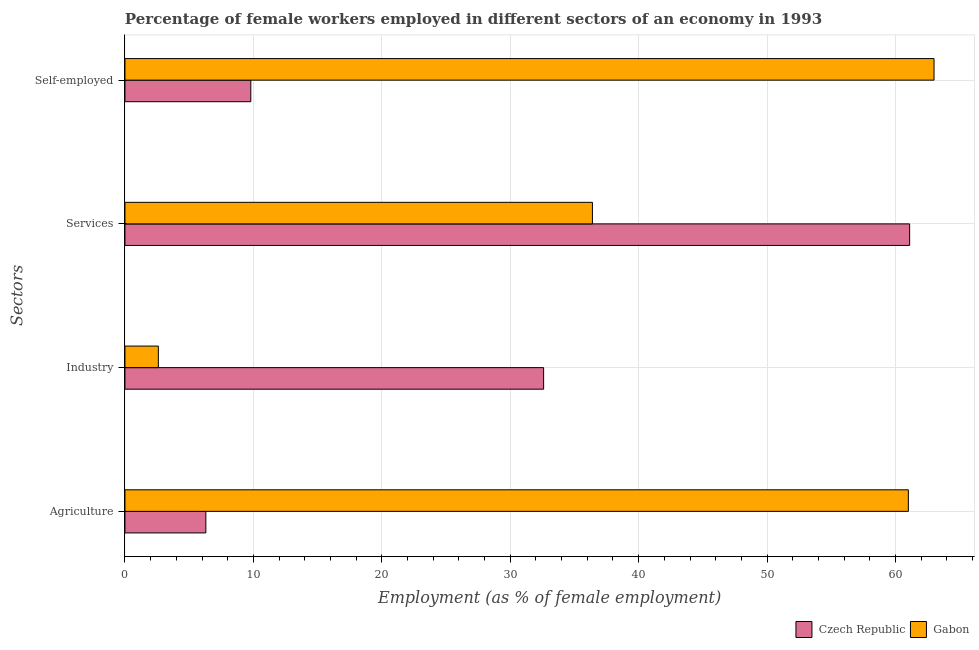How many different coloured bars are there?
Your answer should be compact. 2. How many groups of bars are there?
Make the answer very short. 4. Are the number of bars on each tick of the Y-axis equal?
Give a very brief answer. Yes. What is the label of the 1st group of bars from the top?
Provide a short and direct response. Self-employed. What is the percentage of female workers in services in Czech Republic?
Your response must be concise. 61.1. Across all countries, what is the minimum percentage of female workers in services?
Keep it short and to the point. 36.4. In which country was the percentage of female workers in agriculture maximum?
Provide a short and direct response. Gabon. In which country was the percentage of female workers in services minimum?
Your answer should be very brief. Gabon. What is the total percentage of female workers in agriculture in the graph?
Make the answer very short. 67.3. What is the difference between the percentage of female workers in agriculture in Gabon and that in Czech Republic?
Your answer should be very brief. 54.7. What is the difference between the percentage of female workers in agriculture in Czech Republic and the percentage of female workers in industry in Gabon?
Ensure brevity in your answer.  3.7. What is the average percentage of female workers in services per country?
Keep it short and to the point. 48.75. What is the difference between the percentage of female workers in agriculture and percentage of female workers in services in Gabon?
Provide a short and direct response. 24.6. In how many countries, is the percentage of female workers in services greater than 22 %?
Your response must be concise. 2. What is the ratio of the percentage of female workers in services in Czech Republic to that in Gabon?
Provide a succinct answer. 1.68. Is the percentage of female workers in services in Gabon less than that in Czech Republic?
Offer a very short reply. Yes. What is the difference between the highest and the second highest percentage of female workers in industry?
Your answer should be very brief. 30. What is the difference between the highest and the lowest percentage of female workers in industry?
Your answer should be compact. 30. In how many countries, is the percentage of female workers in industry greater than the average percentage of female workers in industry taken over all countries?
Ensure brevity in your answer.  1. What does the 2nd bar from the top in Self-employed represents?
Ensure brevity in your answer.  Czech Republic. What does the 1st bar from the bottom in Agriculture represents?
Your answer should be very brief. Czech Republic. How many bars are there?
Keep it short and to the point. 8. Are all the bars in the graph horizontal?
Offer a very short reply. Yes. What is the difference between two consecutive major ticks on the X-axis?
Your answer should be compact. 10. Are the values on the major ticks of X-axis written in scientific E-notation?
Provide a succinct answer. No. How are the legend labels stacked?
Provide a short and direct response. Horizontal. What is the title of the graph?
Your answer should be compact. Percentage of female workers employed in different sectors of an economy in 1993. Does "United Kingdom" appear as one of the legend labels in the graph?
Give a very brief answer. No. What is the label or title of the X-axis?
Give a very brief answer. Employment (as % of female employment). What is the label or title of the Y-axis?
Your answer should be compact. Sectors. What is the Employment (as % of female employment) of Czech Republic in Agriculture?
Offer a terse response. 6.3. What is the Employment (as % of female employment) of Gabon in Agriculture?
Offer a very short reply. 61. What is the Employment (as % of female employment) in Czech Republic in Industry?
Give a very brief answer. 32.6. What is the Employment (as % of female employment) of Gabon in Industry?
Offer a very short reply. 2.6. What is the Employment (as % of female employment) in Czech Republic in Services?
Provide a short and direct response. 61.1. What is the Employment (as % of female employment) in Gabon in Services?
Ensure brevity in your answer.  36.4. What is the Employment (as % of female employment) in Czech Republic in Self-employed?
Give a very brief answer. 9.8. What is the Employment (as % of female employment) in Gabon in Self-employed?
Provide a short and direct response. 63. Across all Sectors, what is the maximum Employment (as % of female employment) of Czech Republic?
Offer a very short reply. 61.1. Across all Sectors, what is the maximum Employment (as % of female employment) of Gabon?
Provide a short and direct response. 63. Across all Sectors, what is the minimum Employment (as % of female employment) in Czech Republic?
Keep it short and to the point. 6.3. Across all Sectors, what is the minimum Employment (as % of female employment) of Gabon?
Provide a short and direct response. 2.6. What is the total Employment (as % of female employment) in Czech Republic in the graph?
Keep it short and to the point. 109.8. What is the total Employment (as % of female employment) of Gabon in the graph?
Offer a very short reply. 163. What is the difference between the Employment (as % of female employment) in Czech Republic in Agriculture and that in Industry?
Offer a terse response. -26.3. What is the difference between the Employment (as % of female employment) in Gabon in Agriculture and that in Industry?
Give a very brief answer. 58.4. What is the difference between the Employment (as % of female employment) of Czech Republic in Agriculture and that in Services?
Keep it short and to the point. -54.8. What is the difference between the Employment (as % of female employment) in Gabon in Agriculture and that in Services?
Your response must be concise. 24.6. What is the difference between the Employment (as % of female employment) in Gabon in Agriculture and that in Self-employed?
Give a very brief answer. -2. What is the difference between the Employment (as % of female employment) in Czech Republic in Industry and that in Services?
Provide a short and direct response. -28.5. What is the difference between the Employment (as % of female employment) in Gabon in Industry and that in Services?
Give a very brief answer. -33.8. What is the difference between the Employment (as % of female employment) in Czech Republic in Industry and that in Self-employed?
Your response must be concise. 22.8. What is the difference between the Employment (as % of female employment) of Gabon in Industry and that in Self-employed?
Ensure brevity in your answer.  -60.4. What is the difference between the Employment (as % of female employment) in Czech Republic in Services and that in Self-employed?
Ensure brevity in your answer.  51.3. What is the difference between the Employment (as % of female employment) of Gabon in Services and that in Self-employed?
Offer a very short reply. -26.6. What is the difference between the Employment (as % of female employment) in Czech Republic in Agriculture and the Employment (as % of female employment) in Gabon in Industry?
Your answer should be compact. 3.7. What is the difference between the Employment (as % of female employment) in Czech Republic in Agriculture and the Employment (as % of female employment) in Gabon in Services?
Ensure brevity in your answer.  -30.1. What is the difference between the Employment (as % of female employment) of Czech Republic in Agriculture and the Employment (as % of female employment) of Gabon in Self-employed?
Give a very brief answer. -56.7. What is the difference between the Employment (as % of female employment) of Czech Republic in Industry and the Employment (as % of female employment) of Gabon in Services?
Keep it short and to the point. -3.8. What is the difference between the Employment (as % of female employment) of Czech Republic in Industry and the Employment (as % of female employment) of Gabon in Self-employed?
Keep it short and to the point. -30.4. What is the difference between the Employment (as % of female employment) of Czech Republic in Services and the Employment (as % of female employment) of Gabon in Self-employed?
Your response must be concise. -1.9. What is the average Employment (as % of female employment) in Czech Republic per Sectors?
Ensure brevity in your answer.  27.45. What is the average Employment (as % of female employment) in Gabon per Sectors?
Offer a very short reply. 40.75. What is the difference between the Employment (as % of female employment) of Czech Republic and Employment (as % of female employment) of Gabon in Agriculture?
Offer a very short reply. -54.7. What is the difference between the Employment (as % of female employment) of Czech Republic and Employment (as % of female employment) of Gabon in Services?
Keep it short and to the point. 24.7. What is the difference between the Employment (as % of female employment) in Czech Republic and Employment (as % of female employment) in Gabon in Self-employed?
Provide a short and direct response. -53.2. What is the ratio of the Employment (as % of female employment) in Czech Republic in Agriculture to that in Industry?
Provide a succinct answer. 0.19. What is the ratio of the Employment (as % of female employment) of Gabon in Agriculture to that in Industry?
Offer a terse response. 23.46. What is the ratio of the Employment (as % of female employment) of Czech Republic in Agriculture to that in Services?
Offer a terse response. 0.1. What is the ratio of the Employment (as % of female employment) of Gabon in Agriculture to that in Services?
Give a very brief answer. 1.68. What is the ratio of the Employment (as % of female employment) in Czech Republic in Agriculture to that in Self-employed?
Your answer should be very brief. 0.64. What is the ratio of the Employment (as % of female employment) of Gabon in Agriculture to that in Self-employed?
Give a very brief answer. 0.97. What is the ratio of the Employment (as % of female employment) in Czech Republic in Industry to that in Services?
Ensure brevity in your answer.  0.53. What is the ratio of the Employment (as % of female employment) in Gabon in Industry to that in Services?
Offer a terse response. 0.07. What is the ratio of the Employment (as % of female employment) in Czech Republic in Industry to that in Self-employed?
Make the answer very short. 3.33. What is the ratio of the Employment (as % of female employment) in Gabon in Industry to that in Self-employed?
Your response must be concise. 0.04. What is the ratio of the Employment (as % of female employment) in Czech Republic in Services to that in Self-employed?
Offer a terse response. 6.23. What is the ratio of the Employment (as % of female employment) in Gabon in Services to that in Self-employed?
Your response must be concise. 0.58. What is the difference between the highest and the second highest Employment (as % of female employment) in Gabon?
Your answer should be very brief. 2. What is the difference between the highest and the lowest Employment (as % of female employment) of Czech Republic?
Keep it short and to the point. 54.8. What is the difference between the highest and the lowest Employment (as % of female employment) of Gabon?
Give a very brief answer. 60.4. 